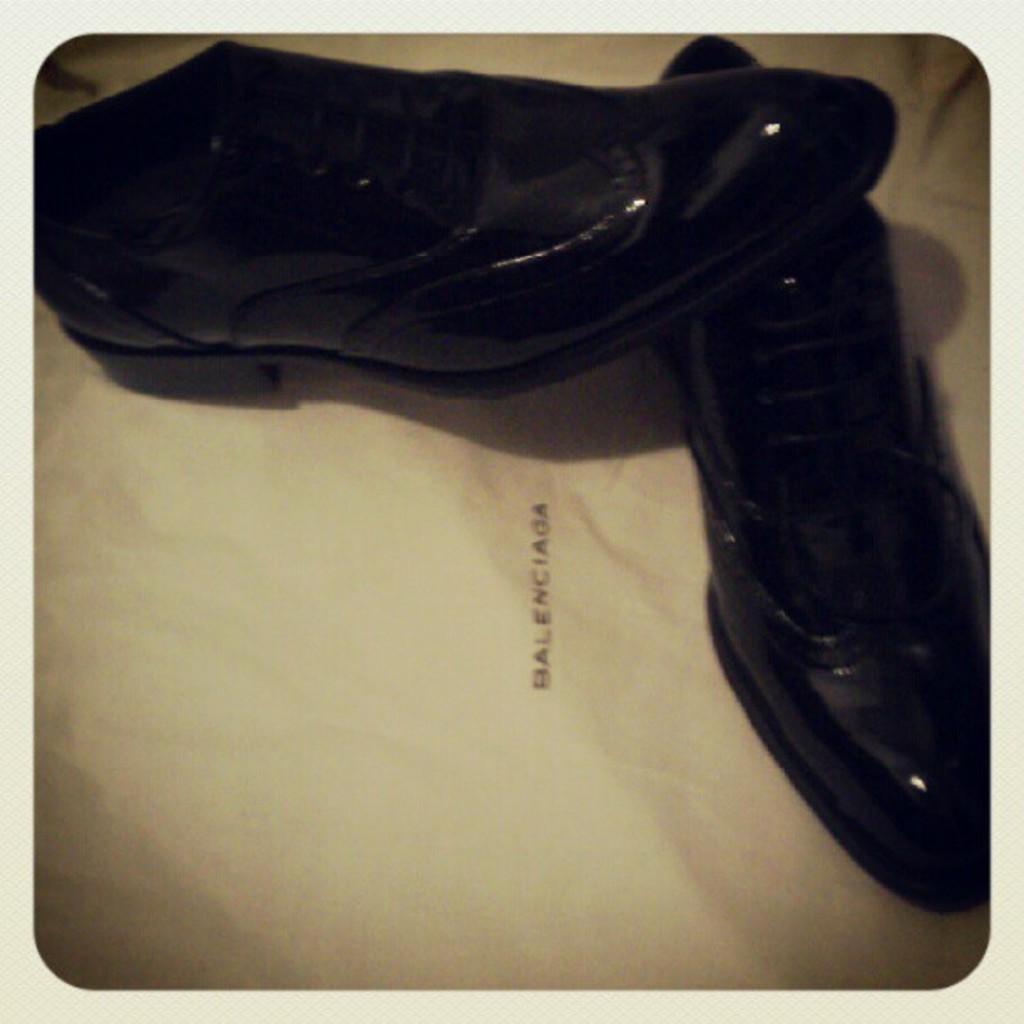Can you describe this image briefly? In the foreground of this image, there are shoes on a white surface. 